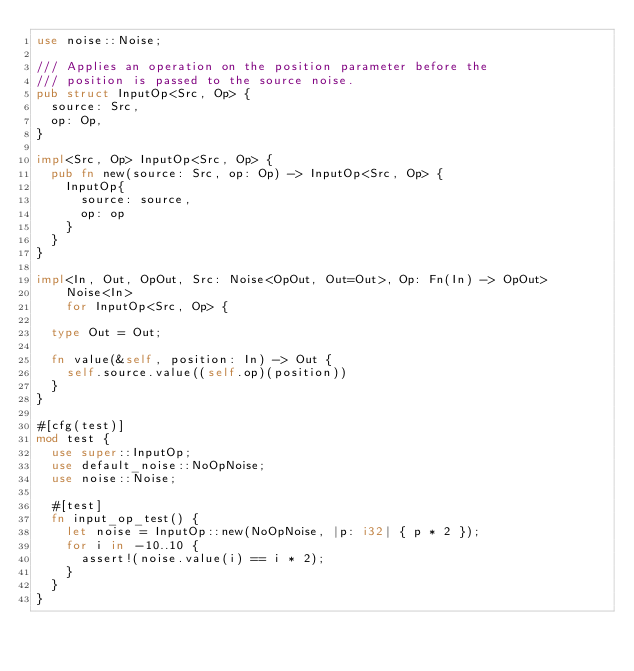<code> <loc_0><loc_0><loc_500><loc_500><_Rust_>use noise::Noise;

/// Applies an operation on the position parameter before the
/// position is passed to the source noise.
pub struct InputOp<Src, Op> {
	source: Src,
	op: Op,
}

impl<Src, Op> InputOp<Src, Op> {
	pub fn new(source: Src, op: Op) -> InputOp<Src, Op> {
		InputOp{
			source: source,
			op: op
		}
	}
}

impl<In, Out, OpOut, Src: Noise<OpOut, Out=Out>, Op: Fn(In) -> OpOut>
		Noise<In>
		for InputOp<Src, Op> {

	type Out = Out;

	fn value(&self, position: In) -> Out {
		self.source.value((self.op)(position))
	}
}

#[cfg(test)]
mod test {
	use super::InputOp;
	use default_noise::NoOpNoise;
	use noise::Noise;

	#[test]
	fn input_op_test() {
		let noise = InputOp::new(NoOpNoise, |p: i32| { p * 2 });
		for i in -10..10 {
			assert!(noise.value(i) == i * 2);
		}
	}
}
</code> 